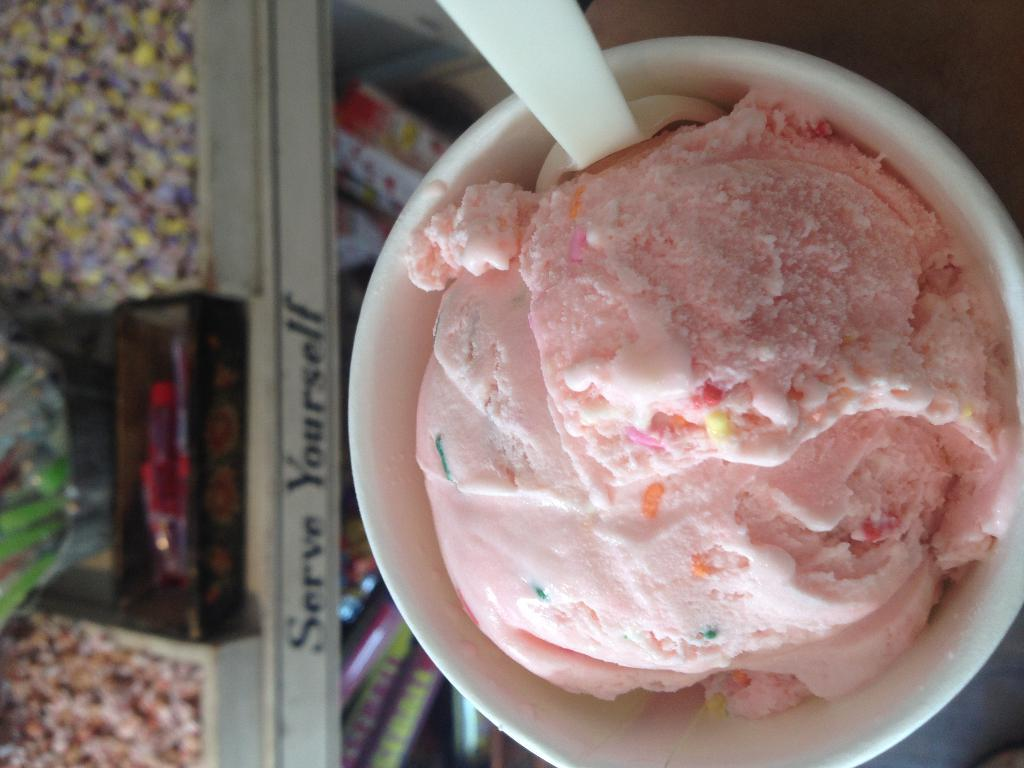What color is the ice cream in the image? The ice cream in the image is pink. How is the ice cream being served? The ice cream is in a cup with a spoon at the top. What is located at the bottom of the cup? There is a glass of a fridge at the bottom of the cup. What type of treats are in the fridge glass? There are chocolates in the fridge glass. Can you see any bees buzzing around the ice cream in the image? There are no bees visible in the image. What type of plants are growing near the ice cream in the image? There are no plants visible in the image. 